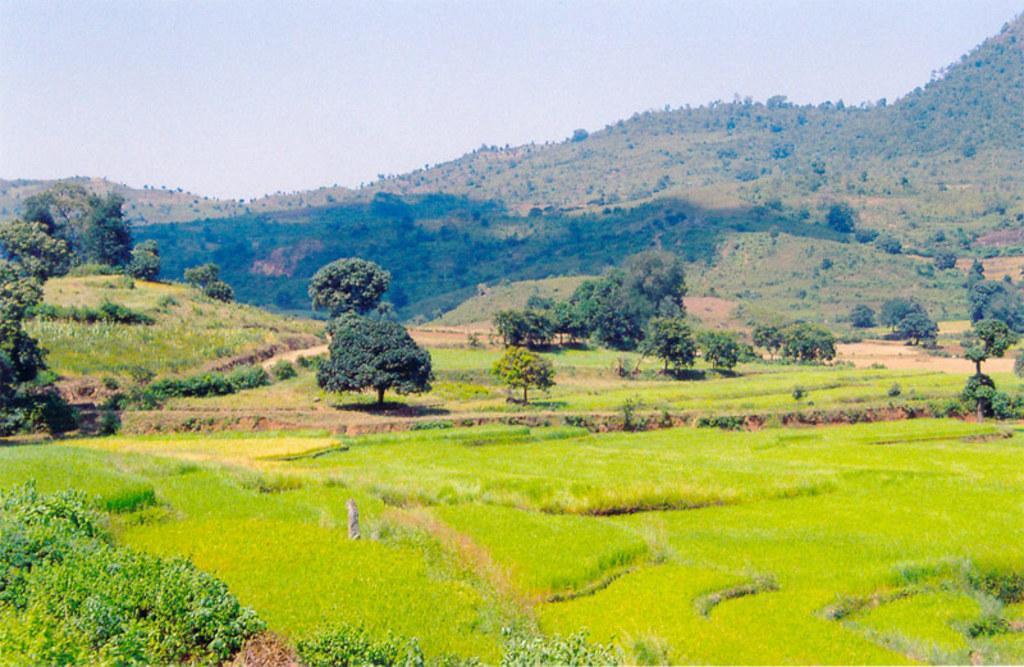Can you describe this image briefly? In the foreground of this image, we see farming fields, plants, trees, mountains and the sky. 